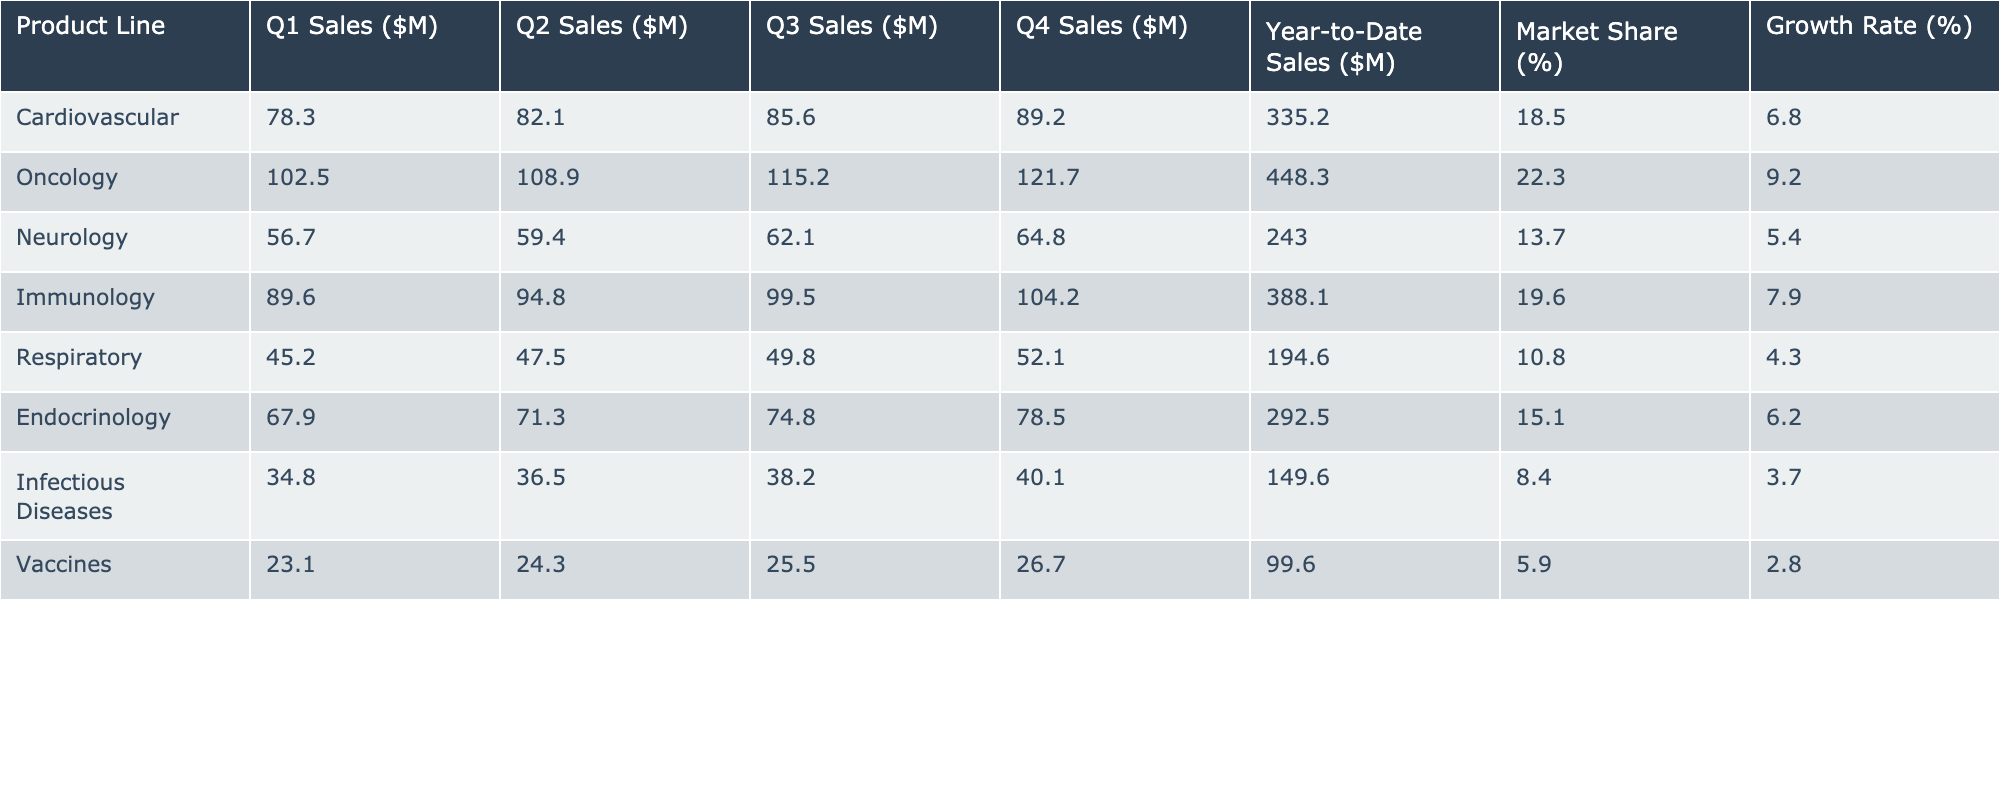What is the total Year-to-Date Sales for the Oncology product line? The Year-to-Date Sales for the Oncology product line is listed in the table as 448.3 million dollars.
Answer: 448.3 million dollars Which product line has the highest Market Share? By comparing the Market Share values in the table, the Oncology product line has the highest at 22.3 percent.
Answer: Oncology What was the Growth Rate for the Respiratory product line? The Growth Rate is provided in the table for the Respiratory product line, which is 4.3 percent.
Answer: 4.3 percent How much was the total Year-to-Date Sales for Cardiovascular and Immunology combined? The Year-to-Date Sales for Cardiovascular is 335.2 million dollars and for Immunology is 388.1 million dollars. Adding these gives 335.2 + 388.1 = 723.3 million dollars.
Answer: 723.3 million dollars Is the Growth Rate for Neurology higher than that for Endocrinology? The Growth Rate for Neurology is 5.4 percent, and for Endocrinology, it is 6.2 percent. Since 5.4 percent is less than 6.2 percent, the statement is false.
Answer: No What is the average Q1 Sales across all product lines? The Q1 Sales values for all product lines are: 78.3, 102.5, 56.7, 89.6, 45.2, 67.9, 34.8, 23.1. The total is 78.3 + 102.5 + 56.7 + 89.6 + 45.2 + 67.9 + 34.8 + 23.1 = 498.1 million dollars. There are 8 product lines, so the average Q1 Sales is 498.1 / 8 = 62.2625 million dollars.
Answer: 62.26 million dollars Which product lines had Year-to-Date Sales over 300 million dollars? The Year-to-Date Sales amounts from the table show that both Oncology (448.3 million) and Immunology (388.1 million) are over 300 million dollars. Therefore, the answer is Oncology and Immunology.
Answer: Oncology and Immunology If we compare Q4 Sales of Cardiovascular and Respiratory, which is greater? The Q4 Sales for Cardiovascular is 89.2 million dollars, and for Respiratory, it is 52.1 million dollars. Since 89.2 is greater than 52.1, Cardiovascular has higher Q4 Sales.
Answer: Cardiovascular Which product line experienced the lowest Growth Rate? By examining the Growth Rate column, the Infectious Diseases product line has the lowest value at 3.7 percent.
Answer: Infectious Diseases What was the total difference in Year-to-Date Sales between Oncology and Cardiovascular? The Year-to-Date Sales for Oncology is 448.3 million dollars and for Cardiovascular is 335.2 million dollars. The difference is 448.3 - 335.2 = 113.1 million dollars.
Answer: 113.1 million dollars Which product line has the lowest Q1 Sales? Looking at the Q1 Sales column, the Vaccines product line has the lowest value of 23.1 million dollars.
Answer: Vaccines 